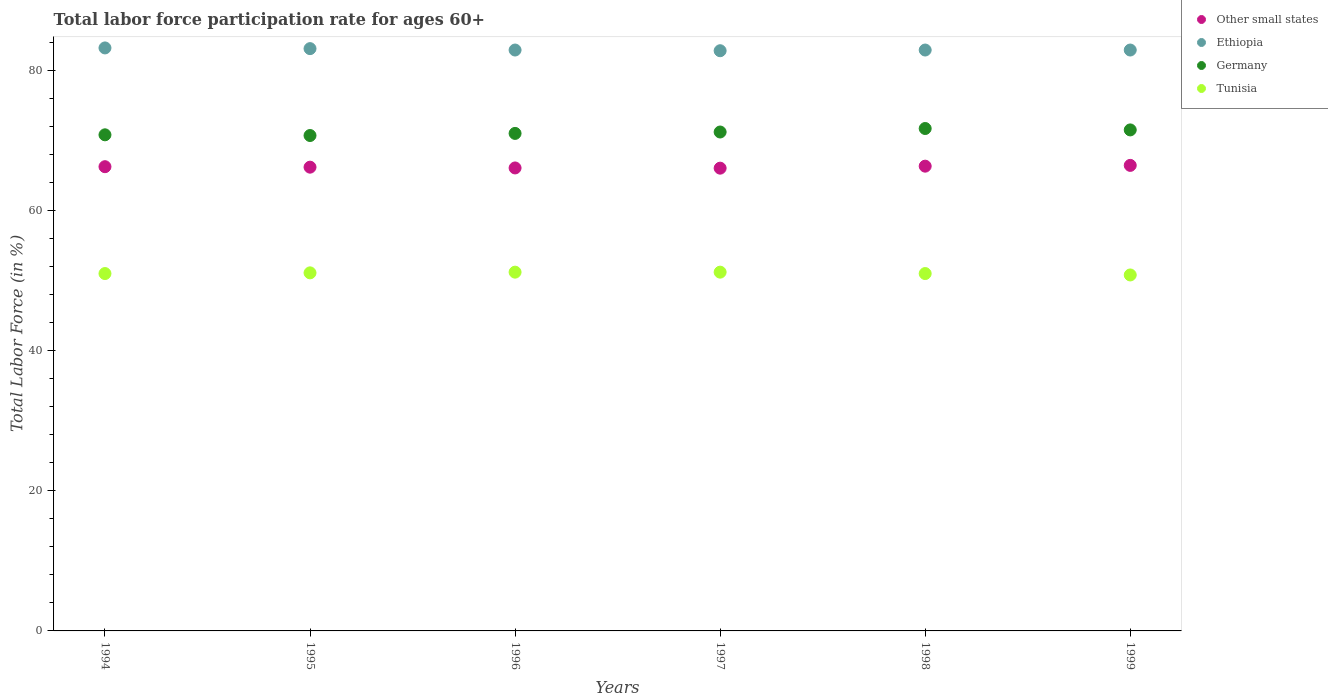How many different coloured dotlines are there?
Offer a terse response. 4. What is the labor force participation rate in Ethiopia in 1995?
Make the answer very short. 83.1. Across all years, what is the maximum labor force participation rate in Tunisia?
Give a very brief answer. 51.2. Across all years, what is the minimum labor force participation rate in Other small states?
Your answer should be compact. 66.04. In which year was the labor force participation rate in Other small states minimum?
Provide a short and direct response. 1997. What is the total labor force participation rate in Other small states in the graph?
Keep it short and to the point. 397.31. What is the difference between the labor force participation rate in Germany in 1996 and that in 1998?
Your answer should be very brief. -0.7. What is the difference between the labor force participation rate in Ethiopia in 1994 and the labor force participation rate in Germany in 1995?
Offer a very short reply. 12.5. What is the average labor force participation rate in Germany per year?
Keep it short and to the point. 71.15. In the year 1994, what is the difference between the labor force participation rate in Ethiopia and labor force participation rate in Other small states?
Provide a short and direct response. 16.95. In how many years, is the labor force participation rate in Other small states greater than 72 %?
Make the answer very short. 0. What is the ratio of the labor force participation rate in Other small states in 1998 to that in 1999?
Your answer should be very brief. 1. Is the labor force participation rate in Tunisia in 1998 less than that in 1999?
Your answer should be very brief. No. Is the difference between the labor force participation rate in Ethiopia in 1995 and 1997 greater than the difference between the labor force participation rate in Other small states in 1995 and 1997?
Keep it short and to the point. Yes. What is the difference between the highest and the second highest labor force participation rate in Tunisia?
Offer a terse response. 0. What is the difference between the highest and the lowest labor force participation rate in Other small states?
Give a very brief answer. 0.4. Is the sum of the labor force participation rate in Other small states in 1995 and 1998 greater than the maximum labor force participation rate in Germany across all years?
Ensure brevity in your answer.  Yes. Is the labor force participation rate in Other small states strictly less than the labor force participation rate in Germany over the years?
Make the answer very short. Yes. How many years are there in the graph?
Make the answer very short. 6. What is the difference between two consecutive major ticks on the Y-axis?
Keep it short and to the point. 20. Does the graph contain any zero values?
Your answer should be very brief. No. Does the graph contain grids?
Your answer should be very brief. No. How many legend labels are there?
Provide a succinct answer. 4. What is the title of the graph?
Make the answer very short. Total labor force participation rate for ages 60+. What is the label or title of the X-axis?
Your answer should be compact. Years. What is the label or title of the Y-axis?
Your answer should be compact. Total Labor Force (in %). What is the Total Labor Force (in %) of Other small states in 1994?
Give a very brief answer. 66.25. What is the Total Labor Force (in %) in Ethiopia in 1994?
Your answer should be very brief. 83.2. What is the Total Labor Force (in %) of Germany in 1994?
Your answer should be compact. 70.8. What is the Total Labor Force (in %) in Tunisia in 1994?
Make the answer very short. 51. What is the Total Labor Force (in %) in Other small states in 1995?
Offer a terse response. 66.18. What is the Total Labor Force (in %) of Ethiopia in 1995?
Ensure brevity in your answer.  83.1. What is the Total Labor Force (in %) of Germany in 1995?
Provide a short and direct response. 70.7. What is the Total Labor Force (in %) of Tunisia in 1995?
Offer a terse response. 51.1. What is the Total Labor Force (in %) in Other small states in 1996?
Give a very brief answer. 66.07. What is the Total Labor Force (in %) of Ethiopia in 1996?
Offer a very short reply. 82.9. What is the Total Labor Force (in %) of Tunisia in 1996?
Keep it short and to the point. 51.2. What is the Total Labor Force (in %) in Other small states in 1997?
Your response must be concise. 66.04. What is the Total Labor Force (in %) in Ethiopia in 1997?
Offer a terse response. 82.8. What is the Total Labor Force (in %) in Germany in 1997?
Provide a succinct answer. 71.2. What is the Total Labor Force (in %) of Tunisia in 1997?
Your response must be concise. 51.2. What is the Total Labor Force (in %) of Other small states in 1998?
Provide a short and direct response. 66.33. What is the Total Labor Force (in %) in Ethiopia in 1998?
Offer a very short reply. 82.9. What is the Total Labor Force (in %) in Germany in 1998?
Your response must be concise. 71.7. What is the Total Labor Force (in %) of Tunisia in 1998?
Your response must be concise. 51. What is the Total Labor Force (in %) of Other small states in 1999?
Offer a terse response. 66.44. What is the Total Labor Force (in %) in Ethiopia in 1999?
Give a very brief answer. 82.9. What is the Total Labor Force (in %) in Germany in 1999?
Provide a succinct answer. 71.5. What is the Total Labor Force (in %) in Tunisia in 1999?
Your answer should be compact. 50.8. Across all years, what is the maximum Total Labor Force (in %) in Other small states?
Your answer should be very brief. 66.44. Across all years, what is the maximum Total Labor Force (in %) of Ethiopia?
Offer a very short reply. 83.2. Across all years, what is the maximum Total Labor Force (in %) of Germany?
Your answer should be very brief. 71.7. Across all years, what is the maximum Total Labor Force (in %) in Tunisia?
Provide a succinct answer. 51.2. Across all years, what is the minimum Total Labor Force (in %) of Other small states?
Offer a terse response. 66.04. Across all years, what is the minimum Total Labor Force (in %) in Ethiopia?
Provide a succinct answer. 82.8. Across all years, what is the minimum Total Labor Force (in %) in Germany?
Provide a short and direct response. 70.7. Across all years, what is the minimum Total Labor Force (in %) in Tunisia?
Give a very brief answer. 50.8. What is the total Total Labor Force (in %) in Other small states in the graph?
Provide a short and direct response. 397.31. What is the total Total Labor Force (in %) of Ethiopia in the graph?
Your answer should be very brief. 497.8. What is the total Total Labor Force (in %) of Germany in the graph?
Make the answer very short. 426.9. What is the total Total Labor Force (in %) of Tunisia in the graph?
Offer a very short reply. 306.3. What is the difference between the Total Labor Force (in %) in Other small states in 1994 and that in 1995?
Provide a succinct answer. 0.07. What is the difference between the Total Labor Force (in %) of Tunisia in 1994 and that in 1995?
Ensure brevity in your answer.  -0.1. What is the difference between the Total Labor Force (in %) in Other small states in 1994 and that in 1996?
Your response must be concise. 0.18. What is the difference between the Total Labor Force (in %) of Ethiopia in 1994 and that in 1996?
Keep it short and to the point. 0.3. What is the difference between the Total Labor Force (in %) of Other small states in 1994 and that in 1997?
Provide a short and direct response. 0.21. What is the difference between the Total Labor Force (in %) of Germany in 1994 and that in 1997?
Provide a succinct answer. -0.4. What is the difference between the Total Labor Force (in %) of Tunisia in 1994 and that in 1997?
Make the answer very short. -0.2. What is the difference between the Total Labor Force (in %) in Other small states in 1994 and that in 1998?
Your answer should be compact. -0.08. What is the difference between the Total Labor Force (in %) in Germany in 1994 and that in 1998?
Provide a short and direct response. -0.9. What is the difference between the Total Labor Force (in %) in Tunisia in 1994 and that in 1998?
Make the answer very short. 0. What is the difference between the Total Labor Force (in %) of Other small states in 1994 and that in 1999?
Ensure brevity in your answer.  -0.19. What is the difference between the Total Labor Force (in %) of Ethiopia in 1994 and that in 1999?
Provide a succinct answer. 0.3. What is the difference between the Total Labor Force (in %) in Tunisia in 1994 and that in 1999?
Offer a terse response. 0.2. What is the difference between the Total Labor Force (in %) of Other small states in 1995 and that in 1996?
Your response must be concise. 0.11. What is the difference between the Total Labor Force (in %) in Ethiopia in 1995 and that in 1996?
Give a very brief answer. 0.2. What is the difference between the Total Labor Force (in %) of Other small states in 1995 and that in 1997?
Give a very brief answer. 0.14. What is the difference between the Total Labor Force (in %) of Germany in 1995 and that in 1997?
Your answer should be very brief. -0.5. What is the difference between the Total Labor Force (in %) in Tunisia in 1995 and that in 1997?
Keep it short and to the point. -0.1. What is the difference between the Total Labor Force (in %) in Other small states in 1995 and that in 1998?
Provide a short and direct response. -0.14. What is the difference between the Total Labor Force (in %) of Ethiopia in 1995 and that in 1998?
Your answer should be compact. 0.2. What is the difference between the Total Labor Force (in %) of Germany in 1995 and that in 1998?
Offer a very short reply. -1. What is the difference between the Total Labor Force (in %) in Tunisia in 1995 and that in 1998?
Keep it short and to the point. 0.1. What is the difference between the Total Labor Force (in %) in Other small states in 1995 and that in 1999?
Ensure brevity in your answer.  -0.25. What is the difference between the Total Labor Force (in %) in Ethiopia in 1995 and that in 1999?
Keep it short and to the point. 0.2. What is the difference between the Total Labor Force (in %) in Germany in 1995 and that in 1999?
Provide a short and direct response. -0.8. What is the difference between the Total Labor Force (in %) of Tunisia in 1995 and that in 1999?
Make the answer very short. 0.3. What is the difference between the Total Labor Force (in %) of Other small states in 1996 and that in 1997?
Offer a very short reply. 0.03. What is the difference between the Total Labor Force (in %) in Other small states in 1996 and that in 1998?
Your answer should be compact. -0.25. What is the difference between the Total Labor Force (in %) of Other small states in 1996 and that in 1999?
Keep it short and to the point. -0.37. What is the difference between the Total Labor Force (in %) in Ethiopia in 1996 and that in 1999?
Your answer should be compact. 0. What is the difference between the Total Labor Force (in %) of Tunisia in 1996 and that in 1999?
Your answer should be compact. 0.4. What is the difference between the Total Labor Force (in %) in Other small states in 1997 and that in 1998?
Offer a very short reply. -0.29. What is the difference between the Total Labor Force (in %) in Germany in 1997 and that in 1998?
Offer a very short reply. -0.5. What is the difference between the Total Labor Force (in %) of Tunisia in 1997 and that in 1998?
Ensure brevity in your answer.  0.2. What is the difference between the Total Labor Force (in %) in Other small states in 1997 and that in 1999?
Keep it short and to the point. -0.4. What is the difference between the Total Labor Force (in %) in Ethiopia in 1997 and that in 1999?
Make the answer very short. -0.1. What is the difference between the Total Labor Force (in %) in Other small states in 1998 and that in 1999?
Your response must be concise. -0.11. What is the difference between the Total Labor Force (in %) in Ethiopia in 1998 and that in 1999?
Offer a terse response. 0. What is the difference between the Total Labor Force (in %) in Tunisia in 1998 and that in 1999?
Make the answer very short. 0.2. What is the difference between the Total Labor Force (in %) in Other small states in 1994 and the Total Labor Force (in %) in Ethiopia in 1995?
Offer a terse response. -16.85. What is the difference between the Total Labor Force (in %) in Other small states in 1994 and the Total Labor Force (in %) in Germany in 1995?
Your answer should be very brief. -4.45. What is the difference between the Total Labor Force (in %) in Other small states in 1994 and the Total Labor Force (in %) in Tunisia in 1995?
Provide a succinct answer. 15.15. What is the difference between the Total Labor Force (in %) of Ethiopia in 1994 and the Total Labor Force (in %) of Germany in 1995?
Provide a succinct answer. 12.5. What is the difference between the Total Labor Force (in %) in Ethiopia in 1994 and the Total Labor Force (in %) in Tunisia in 1995?
Offer a very short reply. 32.1. What is the difference between the Total Labor Force (in %) of Germany in 1994 and the Total Labor Force (in %) of Tunisia in 1995?
Keep it short and to the point. 19.7. What is the difference between the Total Labor Force (in %) of Other small states in 1994 and the Total Labor Force (in %) of Ethiopia in 1996?
Make the answer very short. -16.65. What is the difference between the Total Labor Force (in %) in Other small states in 1994 and the Total Labor Force (in %) in Germany in 1996?
Your answer should be very brief. -4.75. What is the difference between the Total Labor Force (in %) of Other small states in 1994 and the Total Labor Force (in %) of Tunisia in 1996?
Your answer should be very brief. 15.05. What is the difference between the Total Labor Force (in %) in Ethiopia in 1994 and the Total Labor Force (in %) in Germany in 1996?
Provide a short and direct response. 12.2. What is the difference between the Total Labor Force (in %) of Ethiopia in 1994 and the Total Labor Force (in %) of Tunisia in 1996?
Make the answer very short. 32. What is the difference between the Total Labor Force (in %) in Germany in 1994 and the Total Labor Force (in %) in Tunisia in 1996?
Provide a succinct answer. 19.6. What is the difference between the Total Labor Force (in %) in Other small states in 1994 and the Total Labor Force (in %) in Ethiopia in 1997?
Provide a short and direct response. -16.55. What is the difference between the Total Labor Force (in %) in Other small states in 1994 and the Total Labor Force (in %) in Germany in 1997?
Offer a terse response. -4.95. What is the difference between the Total Labor Force (in %) in Other small states in 1994 and the Total Labor Force (in %) in Tunisia in 1997?
Offer a terse response. 15.05. What is the difference between the Total Labor Force (in %) of Ethiopia in 1994 and the Total Labor Force (in %) of Tunisia in 1997?
Offer a terse response. 32. What is the difference between the Total Labor Force (in %) of Germany in 1994 and the Total Labor Force (in %) of Tunisia in 1997?
Keep it short and to the point. 19.6. What is the difference between the Total Labor Force (in %) of Other small states in 1994 and the Total Labor Force (in %) of Ethiopia in 1998?
Give a very brief answer. -16.65. What is the difference between the Total Labor Force (in %) in Other small states in 1994 and the Total Labor Force (in %) in Germany in 1998?
Your response must be concise. -5.45. What is the difference between the Total Labor Force (in %) of Other small states in 1994 and the Total Labor Force (in %) of Tunisia in 1998?
Offer a terse response. 15.25. What is the difference between the Total Labor Force (in %) of Ethiopia in 1994 and the Total Labor Force (in %) of Tunisia in 1998?
Your response must be concise. 32.2. What is the difference between the Total Labor Force (in %) in Germany in 1994 and the Total Labor Force (in %) in Tunisia in 1998?
Offer a very short reply. 19.8. What is the difference between the Total Labor Force (in %) of Other small states in 1994 and the Total Labor Force (in %) of Ethiopia in 1999?
Provide a succinct answer. -16.65. What is the difference between the Total Labor Force (in %) in Other small states in 1994 and the Total Labor Force (in %) in Germany in 1999?
Your answer should be compact. -5.25. What is the difference between the Total Labor Force (in %) of Other small states in 1994 and the Total Labor Force (in %) of Tunisia in 1999?
Offer a very short reply. 15.45. What is the difference between the Total Labor Force (in %) of Ethiopia in 1994 and the Total Labor Force (in %) of Tunisia in 1999?
Give a very brief answer. 32.4. What is the difference between the Total Labor Force (in %) in Germany in 1994 and the Total Labor Force (in %) in Tunisia in 1999?
Offer a very short reply. 20. What is the difference between the Total Labor Force (in %) of Other small states in 1995 and the Total Labor Force (in %) of Ethiopia in 1996?
Provide a short and direct response. -16.72. What is the difference between the Total Labor Force (in %) in Other small states in 1995 and the Total Labor Force (in %) in Germany in 1996?
Provide a succinct answer. -4.82. What is the difference between the Total Labor Force (in %) in Other small states in 1995 and the Total Labor Force (in %) in Tunisia in 1996?
Provide a succinct answer. 14.98. What is the difference between the Total Labor Force (in %) of Ethiopia in 1995 and the Total Labor Force (in %) of Germany in 1996?
Provide a short and direct response. 12.1. What is the difference between the Total Labor Force (in %) in Ethiopia in 1995 and the Total Labor Force (in %) in Tunisia in 1996?
Your response must be concise. 31.9. What is the difference between the Total Labor Force (in %) of Other small states in 1995 and the Total Labor Force (in %) of Ethiopia in 1997?
Your response must be concise. -16.62. What is the difference between the Total Labor Force (in %) in Other small states in 1995 and the Total Labor Force (in %) in Germany in 1997?
Your answer should be very brief. -5.02. What is the difference between the Total Labor Force (in %) of Other small states in 1995 and the Total Labor Force (in %) of Tunisia in 1997?
Your answer should be compact. 14.98. What is the difference between the Total Labor Force (in %) of Ethiopia in 1995 and the Total Labor Force (in %) of Tunisia in 1997?
Ensure brevity in your answer.  31.9. What is the difference between the Total Labor Force (in %) of Other small states in 1995 and the Total Labor Force (in %) of Ethiopia in 1998?
Offer a very short reply. -16.72. What is the difference between the Total Labor Force (in %) in Other small states in 1995 and the Total Labor Force (in %) in Germany in 1998?
Make the answer very short. -5.52. What is the difference between the Total Labor Force (in %) in Other small states in 1995 and the Total Labor Force (in %) in Tunisia in 1998?
Keep it short and to the point. 15.18. What is the difference between the Total Labor Force (in %) of Ethiopia in 1995 and the Total Labor Force (in %) of Germany in 1998?
Make the answer very short. 11.4. What is the difference between the Total Labor Force (in %) of Ethiopia in 1995 and the Total Labor Force (in %) of Tunisia in 1998?
Your answer should be compact. 32.1. What is the difference between the Total Labor Force (in %) of Other small states in 1995 and the Total Labor Force (in %) of Ethiopia in 1999?
Offer a very short reply. -16.72. What is the difference between the Total Labor Force (in %) in Other small states in 1995 and the Total Labor Force (in %) in Germany in 1999?
Offer a very short reply. -5.32. What is the difference between the Total Labor Force (in %) of Other small states in 1995 and the Total Labor Force (in %) of Tunisia in 1999?
Keep it short and to the point. 15.38. What is the difference between the Total Labor Force (in %) of Ethiopia in 1995 and the Total Labor Force (in %) of Tunisia in 1999?
Give a very brief answer. 32.3. What is the difference between the Total Labor Force (in %) in Germany in 1995 and the Total Labor Force (in %) in Tunisia in 1999?
Make the answer very short. 19.9. What is the difference between the Total Labor Force (in %) in Other small states in 1996 and the Total Labor Force (in %) in Ethiopia in 1997?
Give a very brief answer. -16.73. What is the difference between the Total Labor Force (in %) in Other small states in 1996 and the Total Labor Force (in %) in Germany in 1997?
Provide a succinct answer. -5.13. What is the difference between the Total Labor Force (in %) in Other small states in 1996 and the Total Labor Force (in %) in Tunisia in 1997?
Your answer should be compact. 14.87. What is the difference between the Total Labor Force (in %) of Ethiopia in 1996 and the Total Labor Force (in %) of Germany in 1997?
Offer a terse response. 11.7. What is the difference between the Total Labor Force (in %) in Ethiopia in 1996 and the Total Labor Force (in %) in Tunisia in 1997?
Your answer should be very brief. 31.7. What is the difference between the Total Labor Force (in %) of Germany in 1996 and the Total Labor Force (in %) of Tunisia in 1997?
Give a very brief answer. 19.8. What is the difference between the Total Labor Force (in %) of Other small states in 1996 and the Total Labor Force (in %) of Ethiopia in 1998?
Give a very brief answer. -16.83. What is the difference between the Total Labor Force (in %) in Other small states in 1996 and the Total Labor Force (in %) in Germany in 1998?
Your answer should be compact. -5.63. What is the difference between the Total Labor Force (in %) of Other small states in 1996 and the Total Labor Force (in %) of Tunisia in 1998?
Your response must be concise. 15.07. What is the difference between the Total Labor Force (in %) in Ethiopia in 1996 and the Total Labor Force (in %) in Germany in 1998?
Offer a terse response. 11.2. What is the difference between the Total Labor Force (in %) in Ethiopia in 1996 and the Total Labor Force (in %) in Tunisia in 1998?
Provide a succinct answer. 31.9. What is the difference between the Total Labor Force (in %) in Germany in 1996 and the Total Labor Force (in %) in Tunisia in 1998?
Give a very brief answer. 20. What is the difference between the Total Labor Force (in %) of Other small states in 1996 and the Total Labor Force (in %) of Ethiopia in 1999?
Offer a terse response. -16.83. What is the difference between the Total Labor Force (in %) in Other small states in 1996 and the Total Labor Force (in %) in Germany in 1999?
Offer a terse response. -5.43. What is the difference between the Total Labor Force (in %) in Other small states in 1996 and the Total Labor Force (in %) in Tunisia in 1999?
Offer a very short reply. 15.27. What is the difference between the Total Labor Force (in %) in Ethiopia in 1996 and the Total Labor Force (in %) in Tunisia in 1999?
Offer a very short reply. 32.1. What is the difference between the Total Labor Force (in %) of Germany in 1996 and the Total Labor Force (in %) of Tunisia in 1999?
Offer a terse response. 20.2. What is the difference between the Total Labor Force (in %) of Other small states in 1997 and the Total Labor Force (in %) of Ethiopia in 1998?
Provide a short and direct response. -16.86. What is the difference between the Total Labor Force (in %) of Other small states in 1997 and the Total Labor Force (in %) of Germany in 1998?
Offer a terse response. -5.66. What is the difference between the Total Labor Force (in %) of Other small states in 1997 and the Total Labor Force (in %) of Tunisia in 1998?
Provide a short and direct response. 15.04. What is the difference between the Total Labor Force (in %) of Ethiopia in 1997 and the Total Labor Force (in %) of Germany in 1998?
Your answer should be compact. 11.1. What is the difference between the Total Labor Force (in %) of Ethiopia in 1997 and the Total Labor Force (in %) of Tunisia in 1998?
Offer a terse response. 31.8. What is the difference between the Total Labor Force (in %) of Germany in 1997 and the Total Labor Force (in %) of Tunisia in 1998?
Your response must be concise. 20.2. What is the difference between the Total Labor Force (in %) of Other small states in 1997 and the Total Labor Force (in %) of Ethiopia in 1999?
Your response must be concise. -16.86. What is the difference between the Total Labor Force (in %) in Other small states in 1997 and the Total Labor Force (in %) in Germany in 1999?
Your answer should be very brief. -5.46. What is the difference between the Total Labor Force (in %) in Other small states in 1997 and the Total Labor Force (in %) in Tunisia in 1999?
Provide a succinct answer. 15.24. What is the difference between the Total Labor Force (in %) in Ethiopia in 1997 and the Total Labor Force (in %) in Germany in 1999?
Ensure brevity in your answer.  11.3. What is the difference between the Total Labor Force (in %) of Ethiopia in 1997 and the Total Labor Force (in %) of Tunisia in 1999?
Offer a very short reply. 32. What is the difference between the Total Labor Force (in %) of Germany in 1997 and the Total Labor Force (in %) of Tunisia in 1999?
Provide a short and direct response. 20.4. What is the difference between the Total Labor Force (in %) of Other small states in 1998 and the Total Labor Force (in %) of Ethiopia in 1999?
Provide a short and direct response. -16.57. What is the difference between the Total Labor Force (in %) in Other small states in 1998 and the Total Labor Force (in %) in Germany in 1999?
Make the answer very short. -5.17. What is the difference between the Total Labor Force (in %) of Other small states in 1998 and the Total Labor Force (in %) of Tunisia in 1999?
Offer a very short reply. 15.53. What is the difference between the Total Labor Force (in %) in Ethiopia in 1998 and the Total Labor Force (in %) in Germany in 1999?
Your answer should be very brief. 11.4. What is the difference between the Total Labor Force (in %) in Ethiopia in 1998 and the Total Labor Force (in %) in Tunisia in 1999?
Your answer should be very brief. 32.1. What is the difference between the Total Labor Force (in %) of Germany in 1998 and the Total Labor Force (in %) of Tunisia in 1999?
Ensure brevity in your answer.  20.9. What is the average Total Labor Force (in %) in Other small states per year?
Your answer should be very brief. 66.22. What is the average Total Labor Force (in %) of Ethiopia per year?
Keep it short and to the point. 82.97. What is the average Total Labor Force (in %) in Germany per year?
Your answer should be very brief. 71.15. What is the average Total Labor Force (in %) in Tunisia per year?
Provide a succinct answer. 51.05. In the year 1994, what is the difference between the Total Labor Force (in %) in Other small states and Total Labor Force (in %) in Ethiopia?
Give a very brief answer. -16.95. In the year 1994, what is the difference between the Total Labor Force (in %) in Other small states and Total Labor Force (in %) in Germany?
Your answer should be very brief. -4.55. In the year 1994, what is the difference between the Total Labor Force (in %) in Other small states and Total Labor Force (in %) in Tunisia?
Your answer should be very brief. 15.25. In the year 1994, what is the difference between the Total Labor Force (in %) of Ethiopia and Total Labor Force (in %) of Germany?
Provide a short and direct response. 12.4. In the year 1994, what is the difference between the Total Labor Force (in %) in Ethiopia and Total Labor Force (in %) in Tunisia?
Provide a short and direct response. 32.2. In the year 1994, what is the difference between the Total Labor Force (in %) of Germany and Total Labor Force (in %) of Tunisia?
Keep it short and to the point. 19.8. In the year 1995, what is the difference between the Total Labor Force (in %) in Other small states and Total Labor Force (in %) in Ethiopia?
Provide a succinct answer. -16.92. In the year 1995, what is the difference between the Total Labor Force (in %) in Other small states and Total Labor Force (in %) in Germany?
Your response must be concise. -4.52. In the year 1995, what is the difference between the Total Labor Force (in %) in Other small states and Total Labor Force (in %) in Tunisia?
Offer a very short reply. 15.08. In the year 1995, what is the difference between the Total Labor Force (in %) in Ethiopia and Total Labor Force (in %) in Germany?
Keep it short and to the point. 12.4. In the year 1995, what is the difference between the Total Labor Force (in %) of Ethiopia and Total Labor Force (in %) of Tunisia?
Offer a terse response. 32. In the year 1995, what is the difference between the Total Labor Force (in %) of Germany and Total Labor Force (in %) of Tunisia?
Give a very brief answer. 19.6. In the year 1996, what is the difference between the Total Labor Force (in %) in Other small states and Total Labor Force (in %) in Ethiopia?
Provide a succinct answer. -16.83. In the year 1996, what is the difference between the Total Labor Force (in %) of Other small states and Total Labor Force (in %) of Germany?
Ensure brevity in your answer.  -4.93. In the year 1996, what is the difference between the Total Labor Force (in %) in Other small states and Total Labor Force (in %) in Tunisia?
Ensure brevity in your answer.  14.87. In the year 1996, what is the difference between the Total Labor Force (in %) in Ethiopia and Total Labor Force (in %) in Tunisia?
Make the answer very short. 31.7. In the year 1996, what is the difference between the Total Labor Force (in %) in Germany and Total Labor Force (in %) in Tunisia?
Your response must be concise. 19.8. In the year 1997, what is the difference between the Total Labor Force (in %) in Other small states and Total Labor Force (in %) in Ethiopia?
Ensure brevity in your answer.  -16.76. In the year 1997, what is the difference between the Total Labor Force (in %) in Other small states and Total Labor Force (in %) in Germany?
Offer a very short reply. -5.16. In the year 1997, what is the difference between the Total Labor Force (in %) of Other small states and Total Labor Force (in %) of Tunisia?
Make the answer very short. 14.84. In the year 1997, what is the difference between the Total Labor Force (in %) in Ethiopia and Total Labor Force (in %) in Tunisia?
Offer a very short reply. 31.6. In the year 1997, what is the difference between the Total Labor Force (in %) of Germany and Total Labor Force (in %) of Tunisia?
Keep it short and to the point. 20. In the year 1998, what is the difference between the Total Labor Force (in %) in Other small states and Total Labor Force (in %) in Ethiopia?
Your answer should be compact. -16.57. In the year 1998, what is the difference between the Total Labor Force (in %) of Other small states and Total Labor Force (in %) of Germany?
Your answer should be very brief. -5.37. In the year 1998, what is the difference between the Total Labor Force (in %) in Other small states and Total Labor Force (in %) in Tunisia?
Your answer should be compact. 15.33. In the year 1998, what is the difference between the Total Labor Force (in %) in Ethiopia and Total Labor Force (in %) in Tunisia?
Ensure brevity in your answer.  31.9. In the year 1998, what is the difference between the Total Labor Force (in %) in Germany and Total Labor Force (in %) in Tunisia?
Offer a very short reply. 20.7. In the year 1999, what is the difference between the Total Labor Force (in %) in Other small states and Total Labor Force (in %) in Ethiopia?
Ensure brevity in your answer.  -16.46. In the year 1999, what is the difference between the Total Labor Force (in %) of Other small states and Total Labor Force (in %) of Germany?
Your response must be concise. -5.06. In the year 1999, what is the difference between the Total Labor Force (in %) in Other small states and Total Labor Force (in %) in Tunisia?
Offer a terse response. 15.64. In the year 1999, what is the difference between the Total Labor Force (in %) in Ethiopia and Total Labor Force (in %) in Germany?
Provide a succinct answer. 11.4. In the year 1999, what is the difference between the Total Labor Force (in %) of Ethiopia and Total Labor Force (in %) of Tunisia?
Keep it short and to the point. 32.1. In the year 1999, what is the difference between the Total Labor Force (in %) of Germany and Total Labor Force (in %) of Tunisia?
Your response must be concise. 20.7. What is the ratio of the Total Labor Force (in %) in Ethiopia in 1994 to that in 1995?
Provide a succinct answer. 1. What is the ratio of the Total Labor Force (in %) of Germany in 1994 to that in 1995?
Give a very brief answer. 1. What is the ratio of the Total Labor Force (in %) in Tunisia in 1994 to that in 1995?
Your response must be concise. 1. What is the ratio of the Total Labor Force (in %) of Germany in 1994 to that in 1996?
Your response must be concise. 1. What is the ratio of the Total Labor Force (in %) in Other small states in 1994 to that in 1997?
Your answer should be compact. 1. What is the ratio of the Total Labor Force (in %) in Tunisia in 1994 to that in 1997?
Your answer should be compact. 1. What is the ratio of the Total Labor Force (in %) of Other small states in 1994 to that in 1998?
Give a very brief answer. 1. What is the ratio of the Total Labor Force (in %) in Germany in 1994 to that in 1998?
Offer a very short reply. 0.99. What is the ratio of the Total Labor Force (in %) of Germany in 1994 to that in 1999?
Keep it short and to the point. 0.99. What is the ratio of the Total Labor Force (in %) in Germany in 1995 to that in 1996?
Offer a terse response. 1. What is the ratio of the Total Labor Force (in %) in Other small states in 1995 to that in 1997?
Give a very brief answer. 1. What is the ratio of the Total Labor Force (in %) in Other small states in 1995 to that in 1998?
Provide a succinct answer. 1. What is the ratio of the Total Labor Force (in %) of Germany in 1995 to that in 1998?
Give a very brief answer. 0.99. What is the ratio of the Total Labor Force (in %) in Ethiopia in 1995 to that in 1999?
Make the answer very short. 1. What is the ratio of the Total Labor Force (in %) in Tunisia in 1995 to that in 1999?
Ensure brevity in your answer.  1.01. What is the ratio of the Total Labor Force (in %) in Ethiopia in 1996 to that in 1997?
Your response must be concise. 1. What is the ratio of the Total Labor Force (in %) in Germany in 1996 to that in 1997?
Offer a terse response. 1. What is the ratio of the Total Labor Force (in %) in Tunisia in 1996 to that in 1997?
Give a very brief answer. 1. What is the ratio of the Total Labor Force (in %) in Germany in 1996 to that in 1998?
Provide a short and direct response. 0.99. What is the ratio of the Total Labor Force (in %) of Tunisia in 1996 to that in 1998?
Your answer should be very brief. 1. What is the ratio of the Total Labor Force (in %) in Germany in 1996 to that in 1999?
Your answer should be compact. 0.99. What is the ratio of the Total Labor Force (in %) in Tunisia in 1996 to that in 1999?
Offer a very short reply. 1.01. What is the ratio of the Total Labor Force (in %) in Tunisia in 1997 to that in 1998?
Keep it short and to the point. 1. What is the ratio of the Total Labor Force (in %) in Ethiopia in 1997 to that in 1999?
Make the answer very short. 1. What is the ratio of the Total Labor Force (in %) of Tunisia in 1997 to that in 1999?
Your answer should be very brief. 1.01. What is the ratio of the Total Labor Force (in %) in Other small states in 1998 to that in 1999?
Your answer should be compact. 1. What is the ratio of the Total Labor Force (in %) of Ethiopia in 1998 to that in 1999?
Make the answer very short. 1. What is the difference between the highest and the second highest Total Labor Force (in %) in Other small states?
Provide a short and direct response. 0.11. What is the difference between the highest and the second highest Total Labor Force (in %) in Ethiopia?
Give a very brief answer. 0.1. What is the difference between the highest and the second highest Total Labor Force (in %) of Tunisia?
Ensure brevity in your answer.  0. What is the difference between the highest and the lowest Total Labor Force (in %) in Other small states?
Your answer should be compact. 0.4. What is the difference between the highest and the lowest Total Labor Force (in %) of Tunisia?
Your response must be concise. 0.4. 